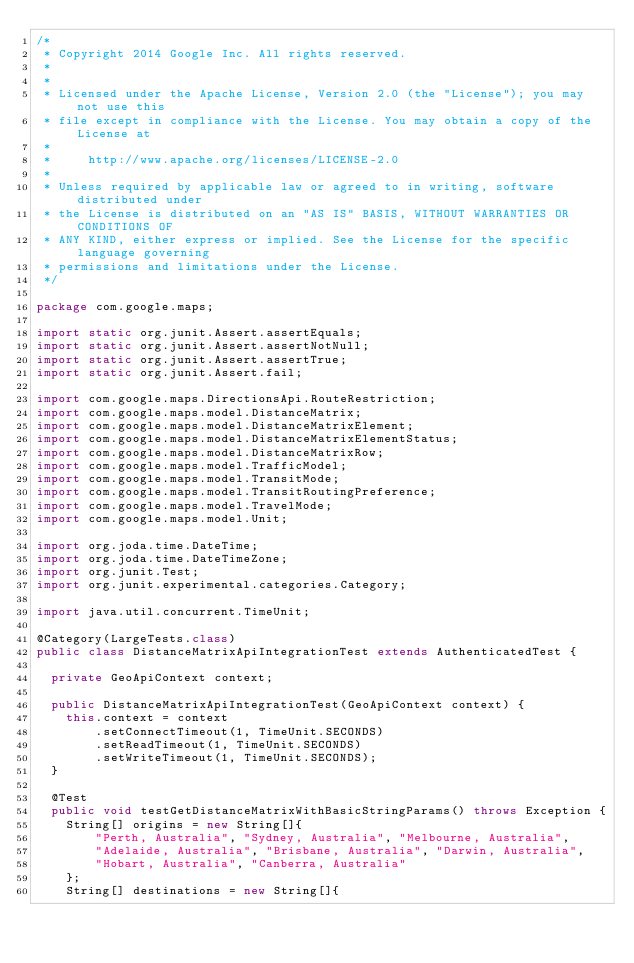Convert code to text. <code><loc_0><loc_0><loc_500><loc_500><_Java_>/*
 * Copyright 2014 Google Inc. All rights reserved.
 *
 *
 * Licensed under the Apache License, Version 2.0 (the "License"); you may not use this
 * file except in compliance with the License. You may obtain a copy of the License at
 *
 *     http://www.apache.org/licenses/LICENSE-2.0
 *
 * Unless required by applicable law or agreed to in writing, software distributed under
 * the License is distributed on an "AS IS" BASIS, WITHOUT WARRANTIES OR CONDITIONS OF
 * ANY KIND, either express or implied. See the License for the specific language governing
 * permissions and limitations under the License.
 */

package com.google.maps;

import static org.junit.Assert.assertEquals;
import static org.junit.Assert.assertNotNull;
import static org.junit.Assert.assertTrue;
import static org.junit.Assert.fail;

import com.google.maps.DirectionsApi.RouteRestriction;
import com.google.maps.model.DistanceMatrix;
import com.google.maps.model.DistanceMatrixElement;
import com.google.maps.model.DistanceMatrixElementStatus;
import com.google.maps.model.DistanceMatrixRow;
import com.google.maps.model.TrafficModel;
import com.google.maps.model.TransitMode;
import com.google.maps.model.TransitRoutingPreference;
import com.google.maps.model.TravelMode;
import com.google.maps.model.Unit;

import org.joda.time.DateTime;
import org.joda.time.DateTimeZone;
import org.junit.Test;
import org.junit.experimental.categories.Category;

import java.util.concurrent.TimeUnit;

@Category(LargeTests.class)
public class DistanceMatrixApiIntegrationTest extends AuthenticatedTest {

  private GeoApiContext context;

  public DistanceMatrixApiIntegrationTest(GeoApiContext context) {
    this.context = context
        .setConnectTimeout(1, TimeUnit.SECONDS)
        .setReadTimeout(1, TimeUnit.SECONDS)
        .setWriteTimeout(1, TimeUnit.SECONDS);
  }

  @Test
  public void testGetDistanceMatrixWithBasicStringParams() throws Exception {
    String[] origins = new String[]{
        "Perth, Australia", "Sydney, Australia", "Melbourne, Australia",
        "Adelaide, Australia", "Brisbane, Australia", "Darwin, Australia",
        "Hobart, Australia", "Canberra, Australia"
    };
    String[] destinations = new String[]{</code> 